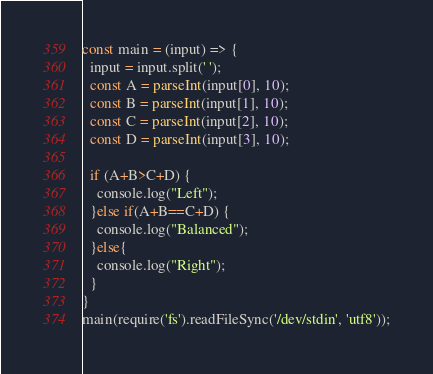Convert code to text. <code><loc_0><loc_0><loc_500><loc_500><_TypeScript_>const main = (input) => {
  input = input.split(' ');
  const A = parseInt(input[0], 10);
  const B = parseInt(input[1], 10);
  const C = parseInt(input[2], 10);
  const D = parseInt(input[3], 10);
  
  if (A+B>C+D) {
    console.log("Left");
  }else if(A+B==C+D) {
    console.log("Balanced"); 
  }else{
    console.log("Right");
  }
}
main(require('fs').readFileSync('/dev/stdin', 'utf8'));</code> 